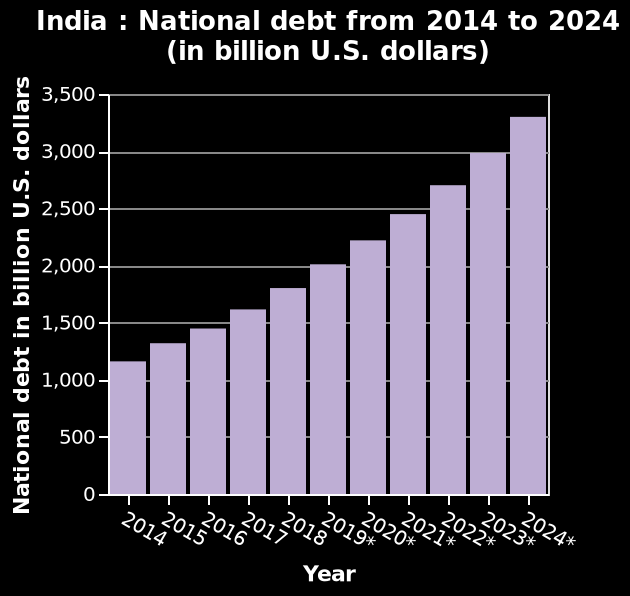<image>
What is the approximate increase in debt every year?  The debt rises by approximately 250 billion every year. What is the annual change in debt? The annual change in debt is an increase of approximately 250 billion. 